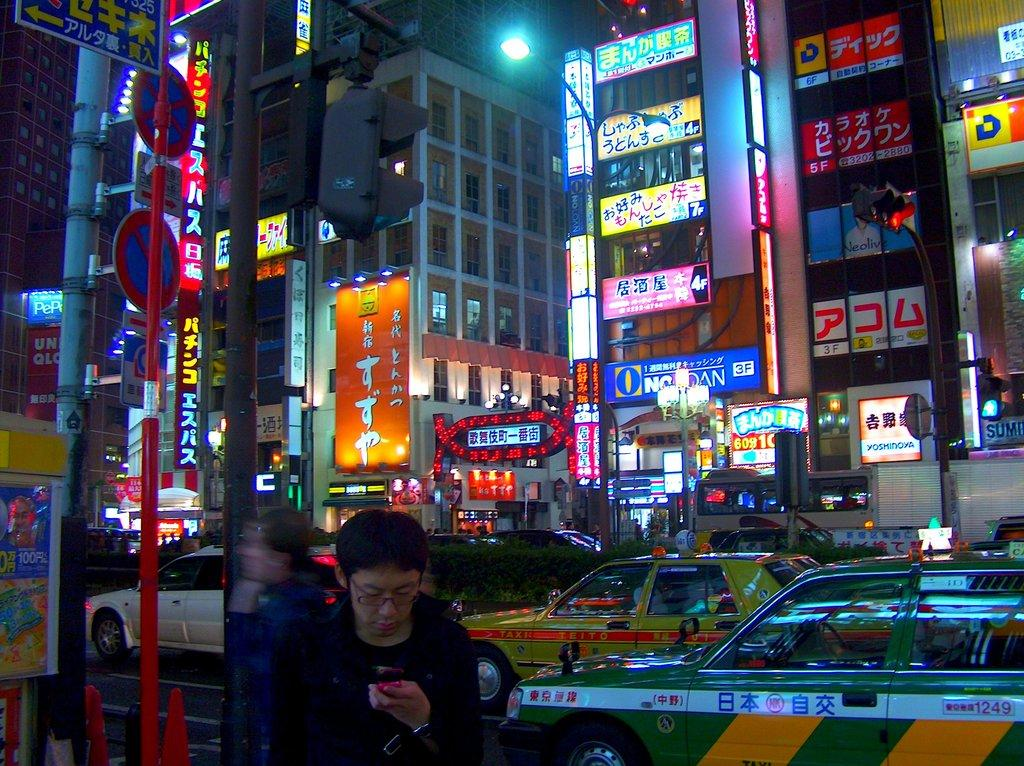<image>
Offer a succinct explanation of the picture presented. Taxi number 1249 is near the edge of this busy street. 